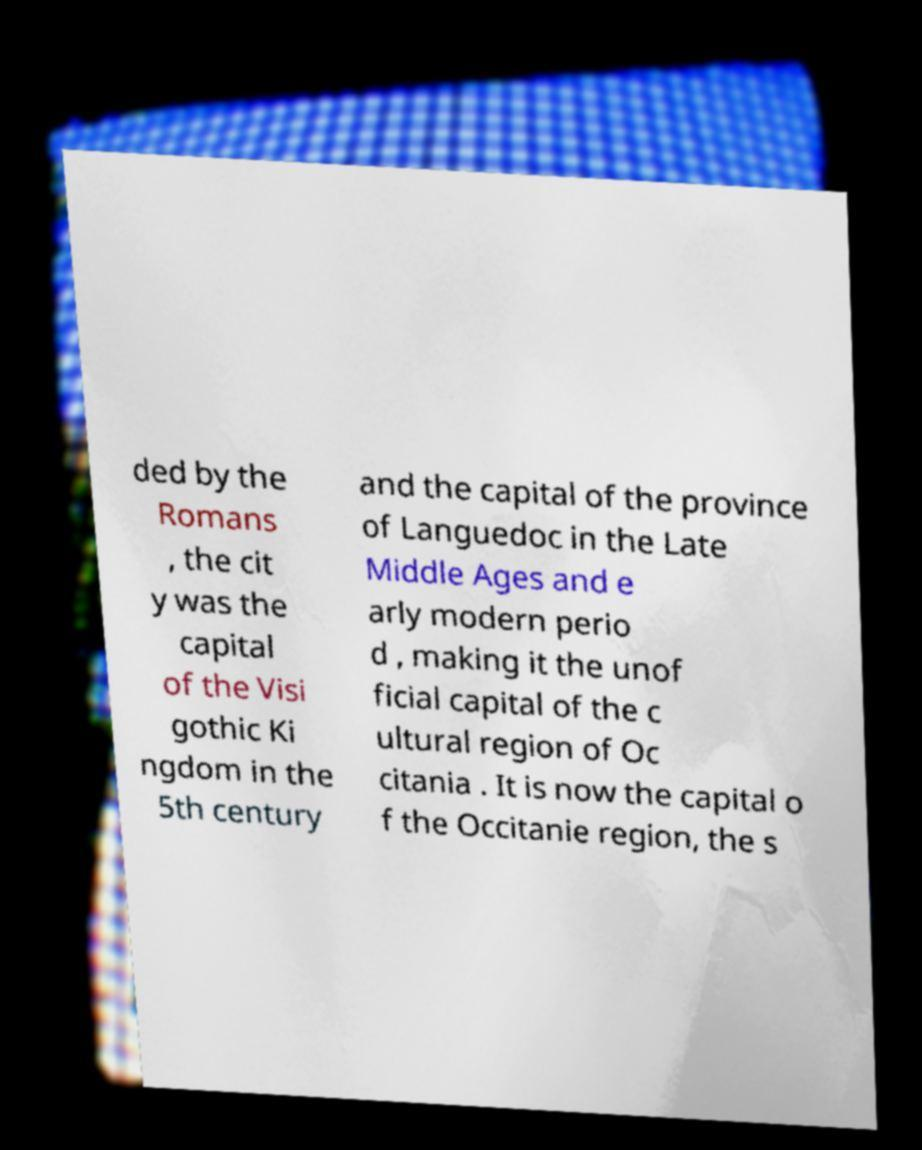Please read and relay the text visible in this image. What does it say? ded by the Romans , the cit y was the capital of the Visi gothic Ki ngdom in the 5th century and the capital of the province of Languedoc in the Late Middle Ages and e arly modern perio d , making it the unof ficial capital of the c ultural region of Oc citania . It is now the capital o f the Occitanie region, the s 